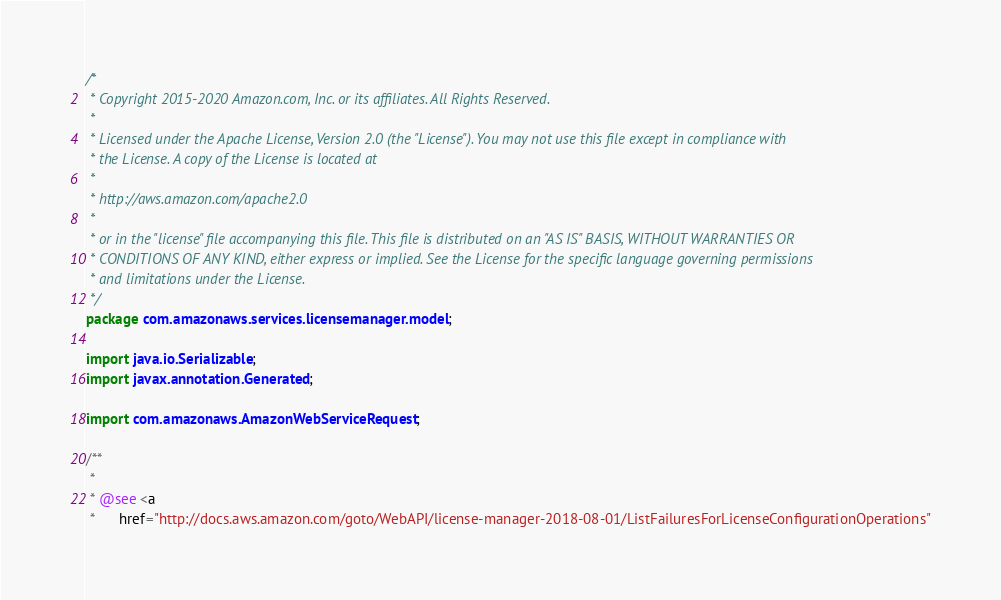<code> <loc_0><loc_0><loc_500><loc_500><_Java_>/*
 * Copyright 2015-2020 Amazon.com, Inc. or its affiliates. All Rights Reserved.
 * 
 * Licensed under the Apache License, Version 2.0 (the "License"). You may not use this file except in compliance with
 * the License. A copy of the License is located at
 * 
 * http://aws.amazon.com/apache2.0
 * 
 * or in the "license" file accompanying this file. This file is distributed on an "AS IS" BASIS, WITHOUT WARRANTIES OR
 * CONDITIONS OF ANY KIND, either express or implied. See the License for the specific language governing permissions
 * and limitations under the License.
 */
package com.amazonaws.services.licensemanager.model;

import java.io.Serializable;
import javax.annotation.Generated;

import com.amazonaws.AmazonWebServiceRequest;

/**
 * 
 * @see <a
 *      href="http://docs.aws.amazon.com/goto/WebAPI/license-manager-2018-08-01/ListFailuresForLicenseConfigurationOperations"</code> 